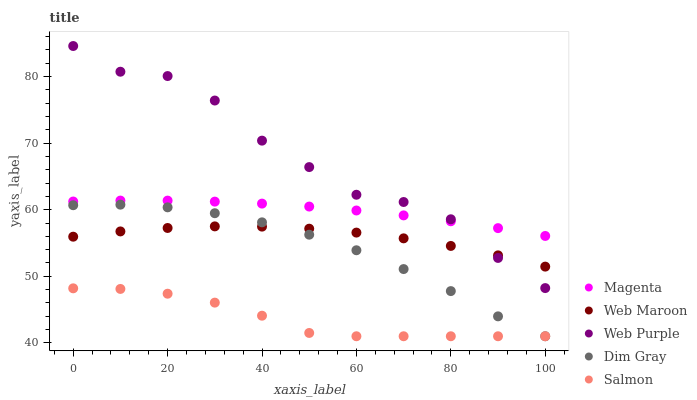Does Salmon have the minimum area under the curve?
Answer yes or no. Yes. Does Web Purple have the maximum area under the curve?
Answer yes or no. Yes. Does Magenta have the minimum area under the curve?
Answer yes or no. No. Does Magenta have the maximum area under the curve?
Answer yes or no. No. Is Magenta the smoothest?
Answer yes or no. Yes. Is Web Purple the roughest?
Answer yes or no. Yes. Is Dim Gray the smoothest?
Answer yes or no. No. Is Dim Gray the roughest?
Answer yes or no. No. Does Salmon have the lowest value?
Answer yes or no. Yes. Does Magenta have the lowest value?
Answer yes or no. No. Does Web Purple have the highest value?
Answer yes or no. Yes. Does Magenta have the highest value?
Answer yes or no. No. Is Salmon less than Web Purple?
Answer yes or no. Yes. Is Magenta greater than Web Maroon?
Answer yes or no. Yes. Does Web Purple intersect Web Maroon?
Answer yes or no. Yes. Is Web Purple less than Web Maroon?
Answer yes or no. No. Is Web Purple greater than Web Maroon?
Answer yes or no. No. Does Salmon intersect Web Purple?
Answer yes or no. No. 